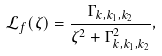<formula> <loc_0><loc_0><loc_500><loc_500>\mathcal { L } _ { f } ( \zeta ) = \frac { \Gamma _ { k , k _ { 1 } , k _ { 2 } } } { \zeta ^ { 2 } + \Gamma _ { k , k _ { 1 } , k _ { 2 } } ^ { 2 } } ,</formula> 